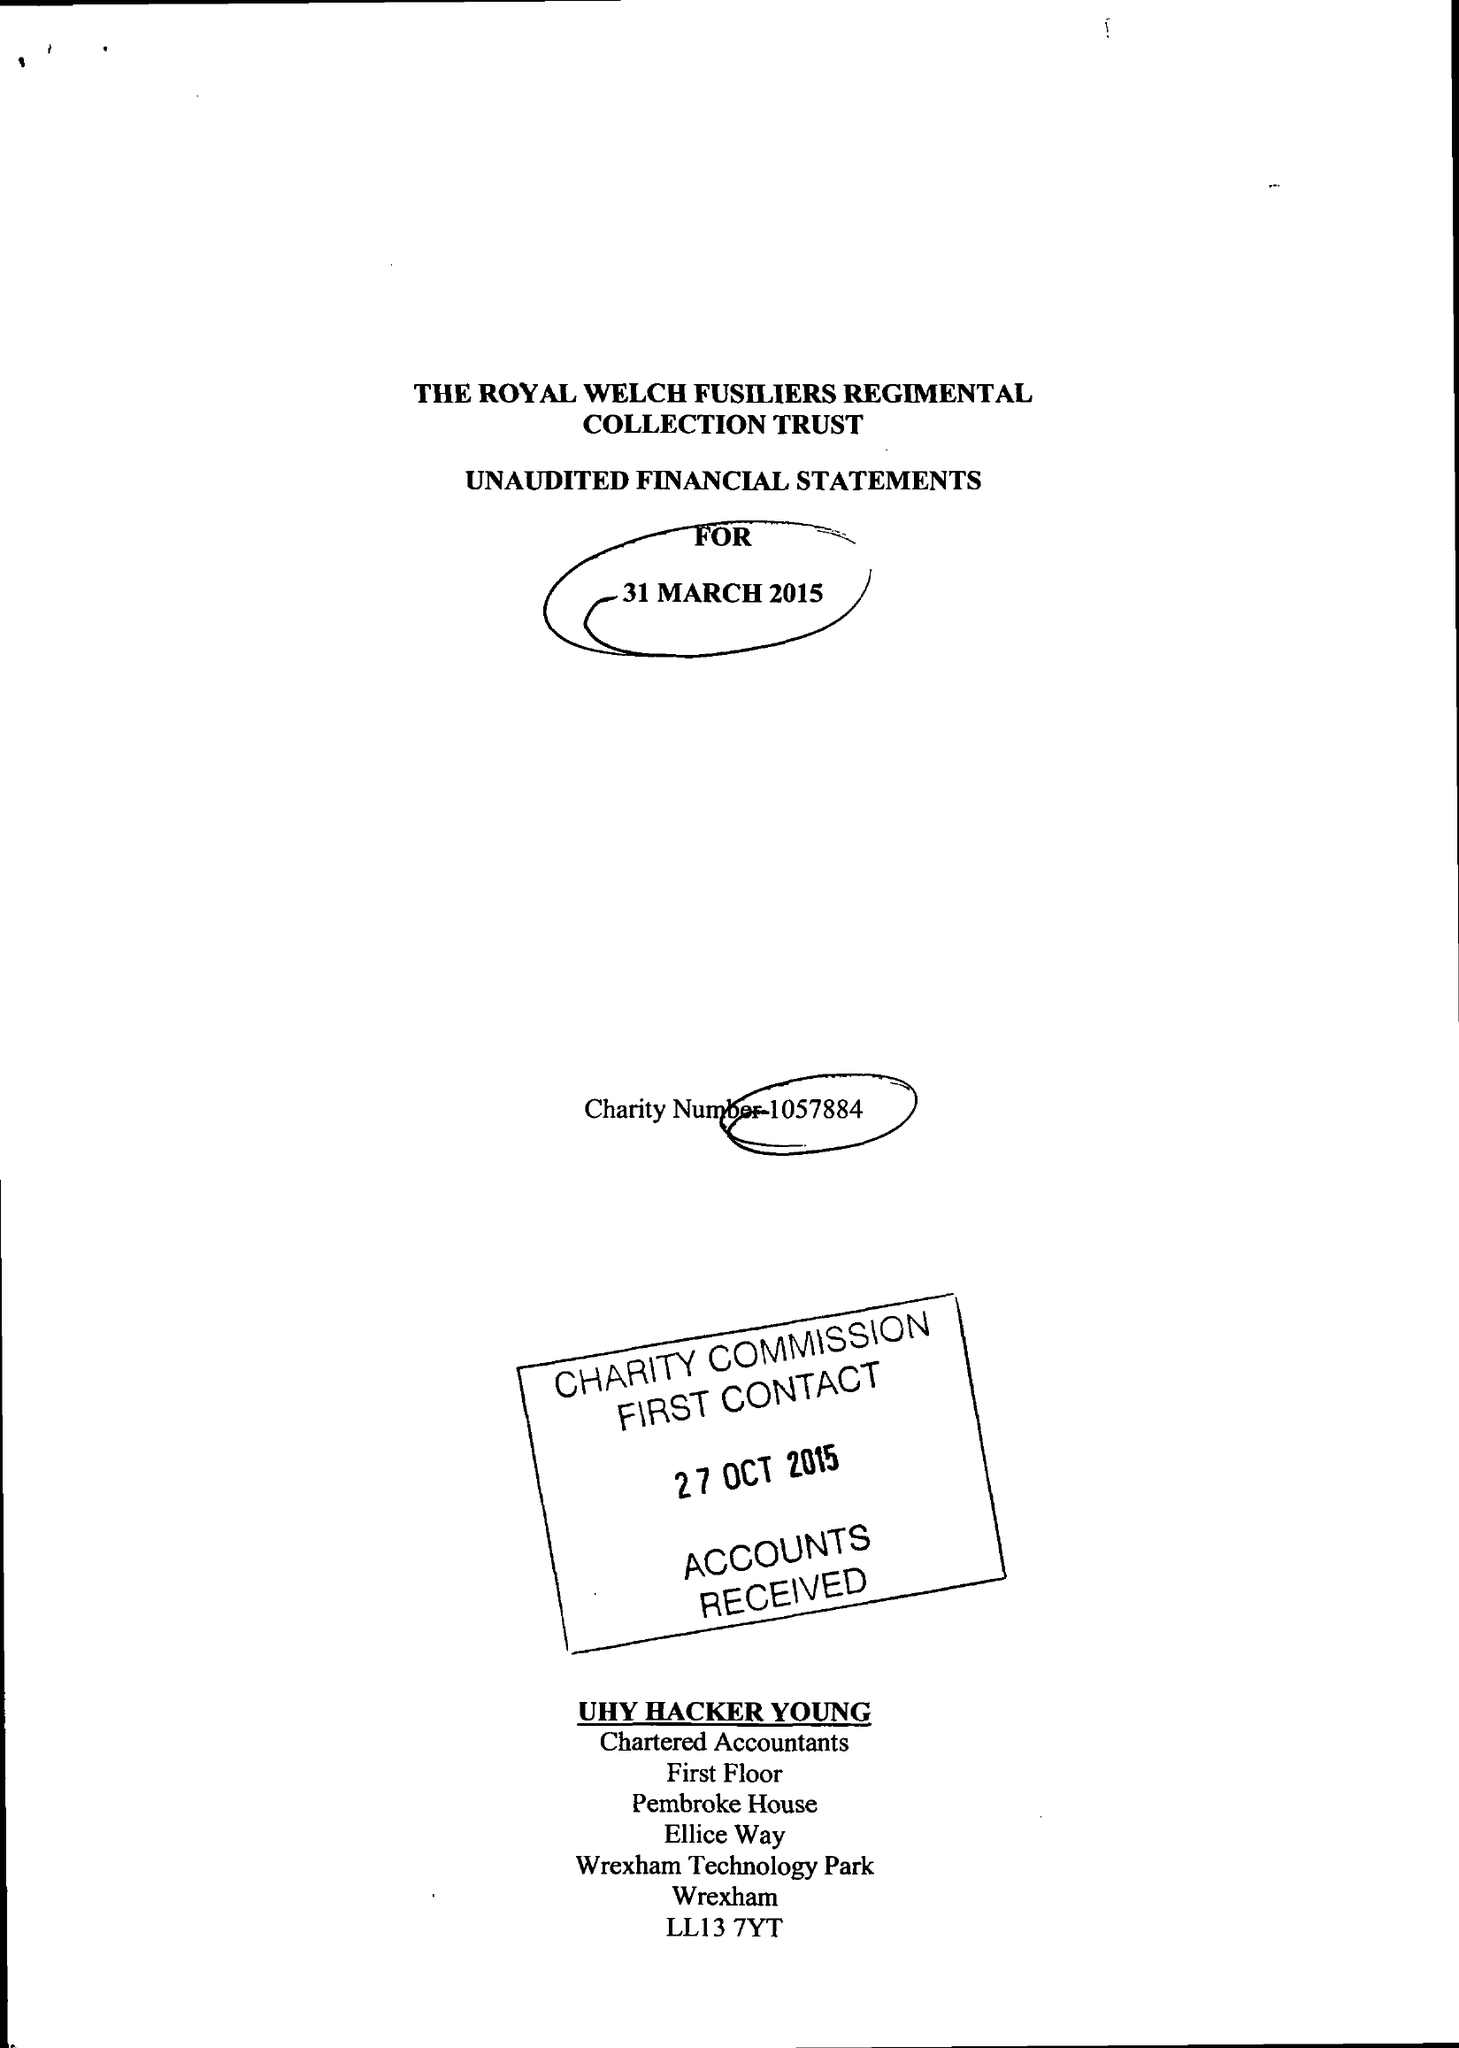What is the value for the charity_name?
Answer the question using a single word or phrase. The Royal Welch Fusiliers Regimental Collection (R.W.F. Collection) 